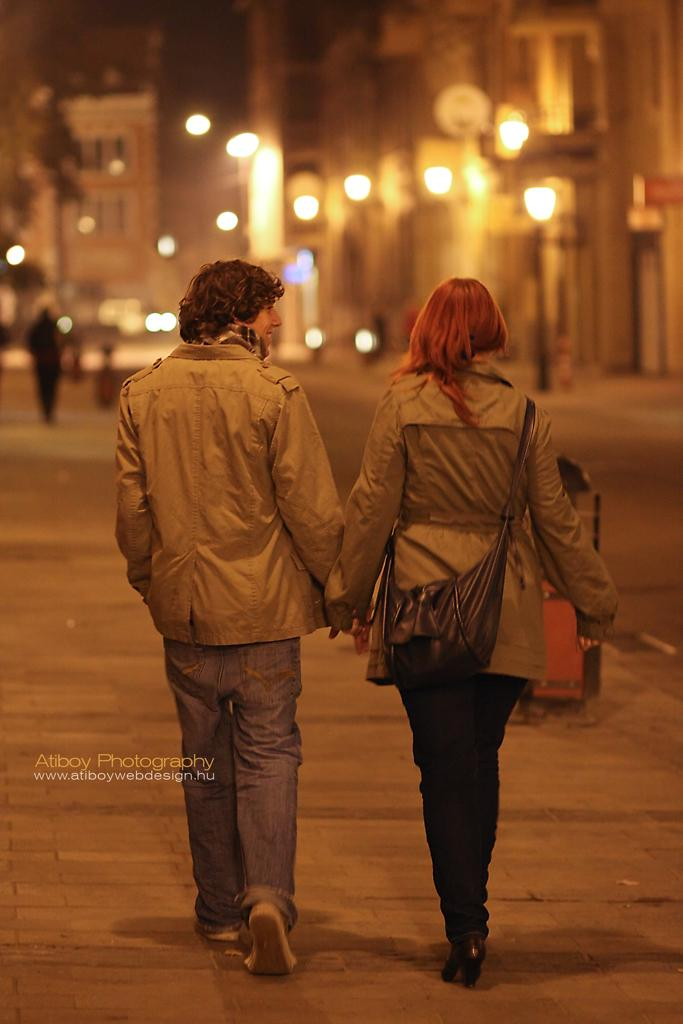Who can be seen in the image? There is a guy and a lady in the image. What are the guy and the lady wearing? Both the guy and the lady are wearing jackets. What can be seen in the background of the image? There are buildings and lights visible in the background of the image. What type of straw is the guy holding in the image? There is no straw present in the image; the guy and the lady are both wearing jackets. What is the lady doing with her wrist in the image? There is no indication of the lady doing anything with her wrist in the image. 